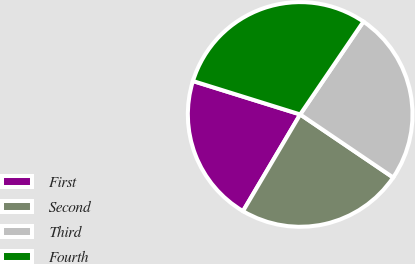<chart> <loc_0><loc_0><loc_500><loc_500><pie_chart><fcel>First<fcel>Second<fcel>Third<fcel>Fourth<nl><fcel>21.31%<fcel>24.02%<fcel>24.97%<fcel>29.71%<nl></chart> 